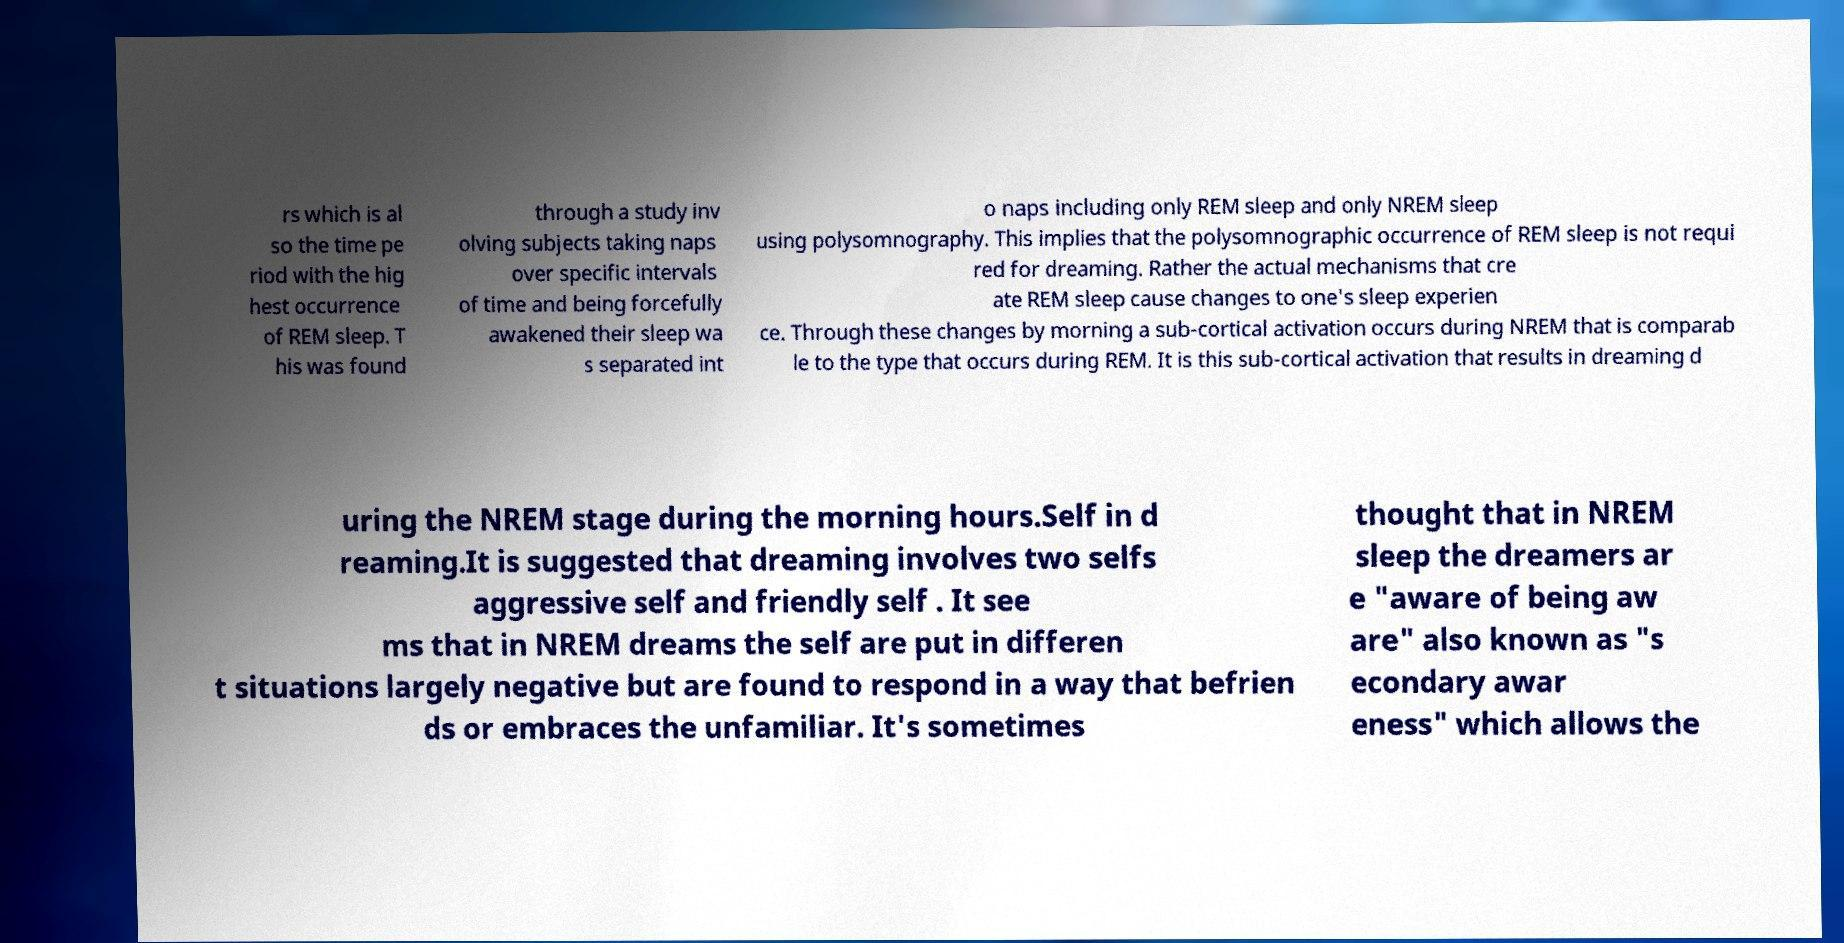Could you extract and type out the text from this image? rs which is al so the time pe riod with the hig hest occurrence of REM sleep. T his was found through a study inv olving subjects taking naps over specific intervals of time and being forcefully awakened their sleep wa s separated int o naps including only REM sleep and only NREM sleep using polysomnography. This implies that the polysomnographic occurrence of REM sleep is not requi red for dreaming. Rather the actual mechanisms that cre ate REM sleep cause changes to one's sleep experien ce. Through these changes by morning a sub-cortical activation occurs during NREM that is comparab le to the type that occurs during REM. It is this sub-cortical activation that results in dreaming d uring the NREM stage during the morning hours.Self in d reaming.It is suggested that dreaming involves two selfs aggressive self and friendly self . It see ms that in NREM dreams the self are put in differen t situations largely negative but are found to respond in a way that befrien ds or embraces the unfamiliar. It's sometimes thought that in NREM sleep the dreamers ar e "aware of being aw are" also known as "s econdary awar eness" which allows the 